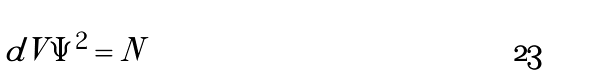<formula> <loc_0><loc_0><loc_500><loc_500>\int d V | \Psi | ^ { 2 } = N</formula> 